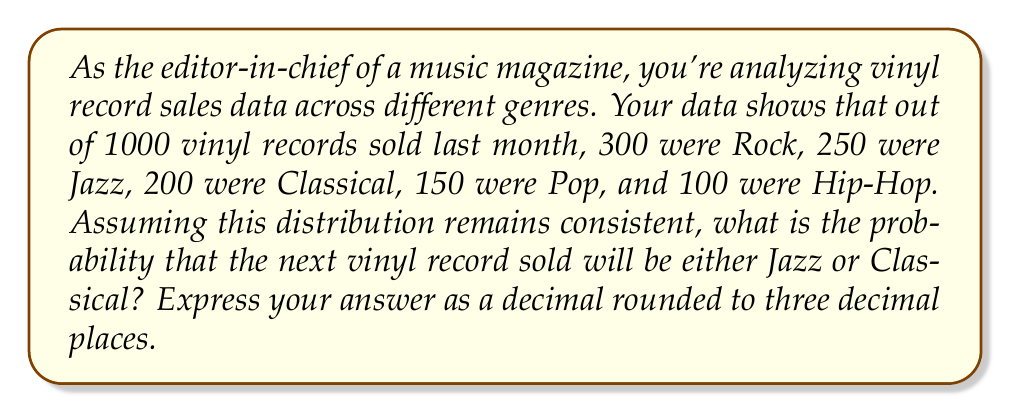Can you answer this question? To solve this problem, we need to understand the concept of probability distribution and how to calculate probabilities based on observed frequencies.

1. First, let's identify the total number of records sold and the number for each genre:
   Total: 1000
   Rock: 300
   Jazz: 250
   Classical: 200
   Pop: 150
   Hip-Hop: 100

2. The probability of an event is calculated by dividing the number of favorable outcomes by the total number of possible outcomes. In this case, we want the probability of a record being either Jazz or Classical.

3. For Jazz:
   $P(\text{Jazz}) = \frac{250}{1000} = 0.25$

4. For Classical:
   $P(\text{Classical}) = \frac{200}{1000} = 0.20$

5. Since we want the probability of either Jazz or Classical, we add these probabilities:
   $P(\text{Jazz or Classical}) = P(\text{Jazz}) + P(\text{Classical})$
   $P(\text{Jazz or Classical}) = 0.25 + 0.20 = 0.45$

6. Rounding to three decimal places:
   $0.45 = 0.450$

Therefore, the probability that the next vinyl record sold will be either Jazz or Classical is 0.450 or 45.0%.
Answer: 0.450 